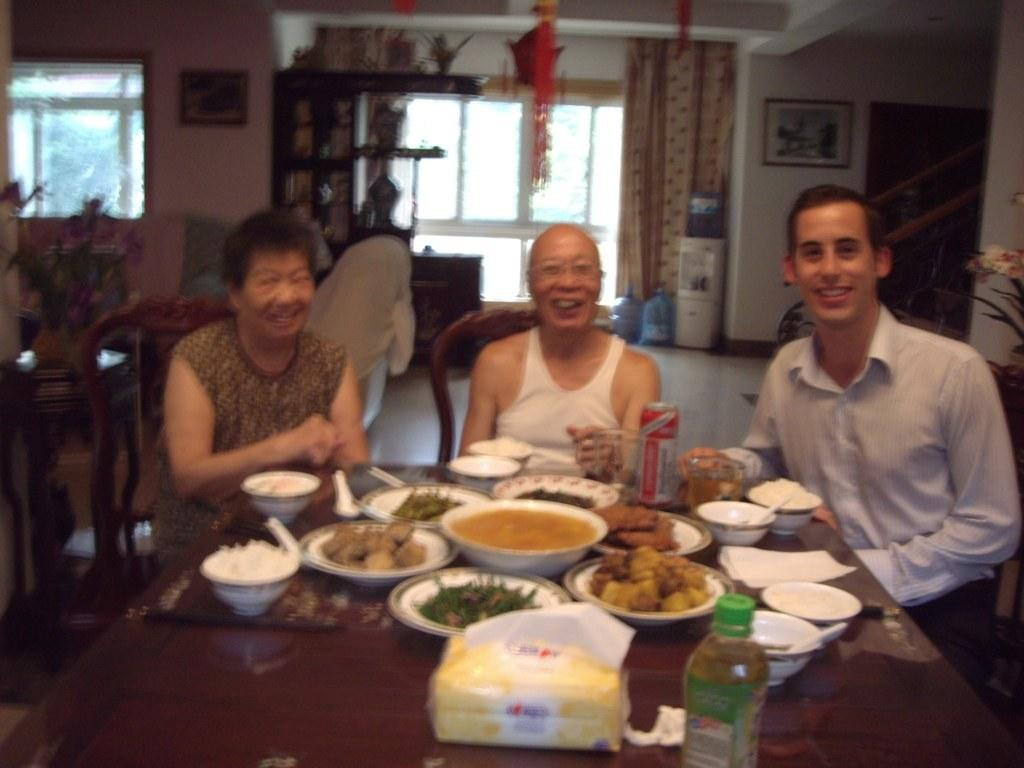How many people are in the image? There are three men in the image. What are the men doing in the image? The men are seated on chairs. What can be seen on the table in the image? There are food items in bowls on the table. What type of yoke is being used by the men in the image? There is no yoke present in the image. Can you see any rays of light shining on the men in the image? The image does not provide information about rays of light. 